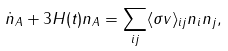Convert formula to latex. <formula><loc_0><loc_0><loc_500><loc_500>\dot { n } _ { A } + 3 H ( t ) n _ { A } = \sum _ { i j } \langle \sigma v \rangle _ { i j } n _ { i } n _ { j } ,</formula> 